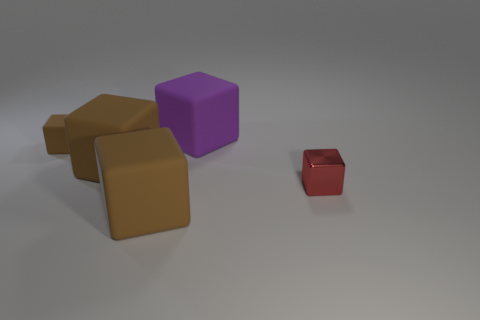What number of other things are made of the same material as the purple object?
Offer a terse response. 3. What number of things are large brown objects or brown rubber objects in front of the red shiny cube?
Keep it short and to the point. 2. What number of tiny red metal cubes are in front of the big block right of the large block that is in front of the tiny red shiny thing?
Keep it short and to the point. 1. There is a small thing that is the same material as the big purple cube; what color is it?
Your answer should be very brief. Brown. Is the size of the brown object in front of the red shiny object the same as the small matte object?
Provide a short and direct response. No. How many objects are either tiny red metal blocks or purple rubber blocks?
Your response must be concise. 2. What is the material of the small cube to the left of the purple matte object on the left side of the object on the right side of the big purple matte thing?
Offer a very short reply. Rubber. There is a large brown object behind the red metal thing; what is its material?
Your response must be concise. Rubber. Is there a red shiny ball that has the same size as the purple object?
Your answer should be very brief. No. There is a cube in front of the small red block; is its color the same as the shiny object?
Your response must be concise. No. 